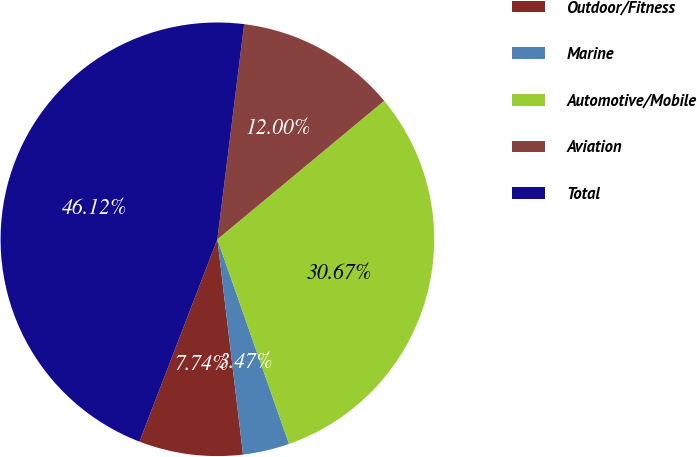Convert chart to OTSL. <chart><loc_0><loc_0><loc_500><loc_500><pie_chart><fcel>Outdoor/Fitness<fcel>Marine<fcel>Automotive/Mobile<fcel>Aviation<fcel>Total<nl><fcel>7.74%<fcel>3.47%<fcel>30.67%<fcel>12.0%<fcel>46.12%<nl></chart> 